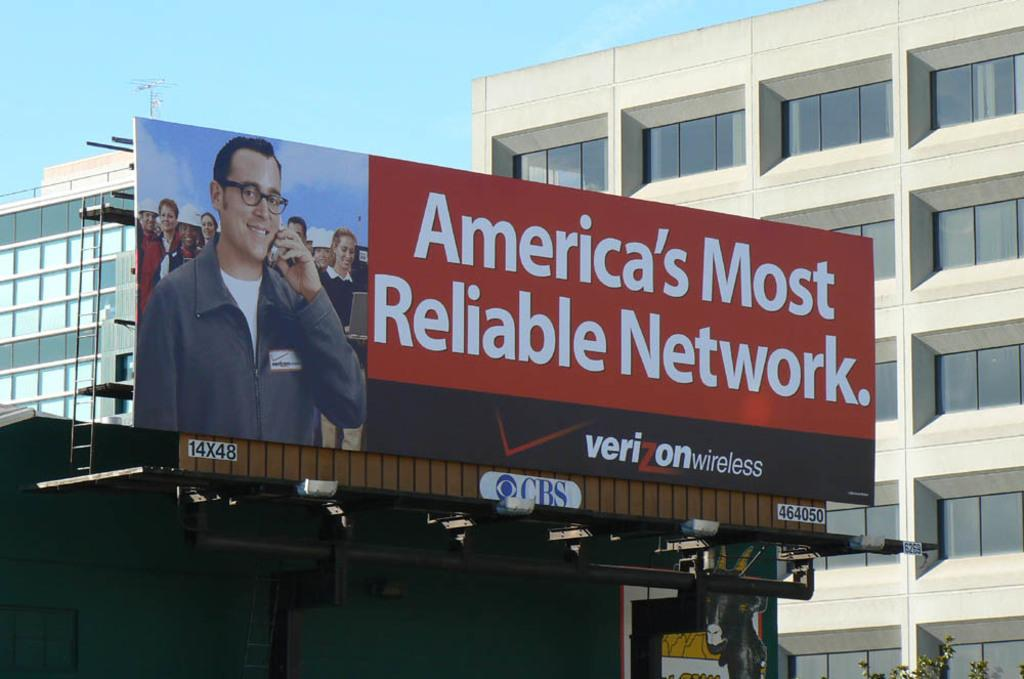What is the main object in the image? There is an advertisement board in the image. What can be seen in the background of the image? There are buildings around the advertisement board. What color is the soap on the advertisement board? There is no soap present on the advertisement board in the image. 